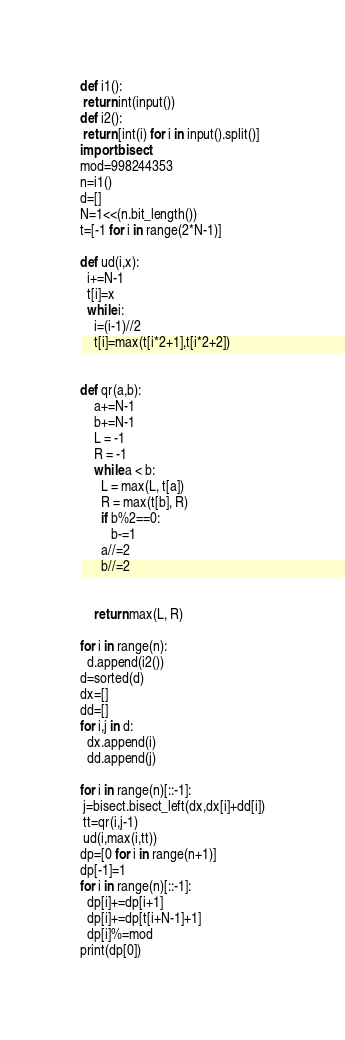Convert code to text. <code><loc_0><loc_0><loc_500><loc_500><_Python_>def i1():
 return int(input())
def i2():
 return [int(i) for i in input().split()]
import bisect
mod=998244353
n=i1()
d=[]
N=1<<(n.bit_length())
t=[-1 for i in range(2*N-1)]

def ud(i,x):
  i+=N-1
  t[i]=x
  while i:
    i=(i-1)//2
    t[i]=max(t[i*2+1],t[i*2+2]) 
     

def qr(a,b):
    a+=N-1
    b+=N-1
    L = -1
    R = -1
    while a < b:
      L = max(L, t[a])
      R = max(t[b], R)
      if b%2==0:
         b-=1
      a//=2
      b//=2
      
         
    return max(L, R)
 
for i in range(n):
  d.append(i2())
d=sorted(d)
dx=[]
dd=[]
for i,j in d:
  dx.append(i)
  dd.append(j)

for i in range(n)[::-1]:
 j=bisect.bisect_left(dx,dx[i]+dd[i])
 tt=qr(i,j-1)
 ud(i,max(i,tt))
dp=[0 for i in range(n+1)]
dp[-1]=1
for i in range(n)[::-1]:
  dp[i]+=dp[i+1]
  dp[i]+=dp[t[i+N-1]+1]
  dp[i]%=mod
print(dp[0])</code> 